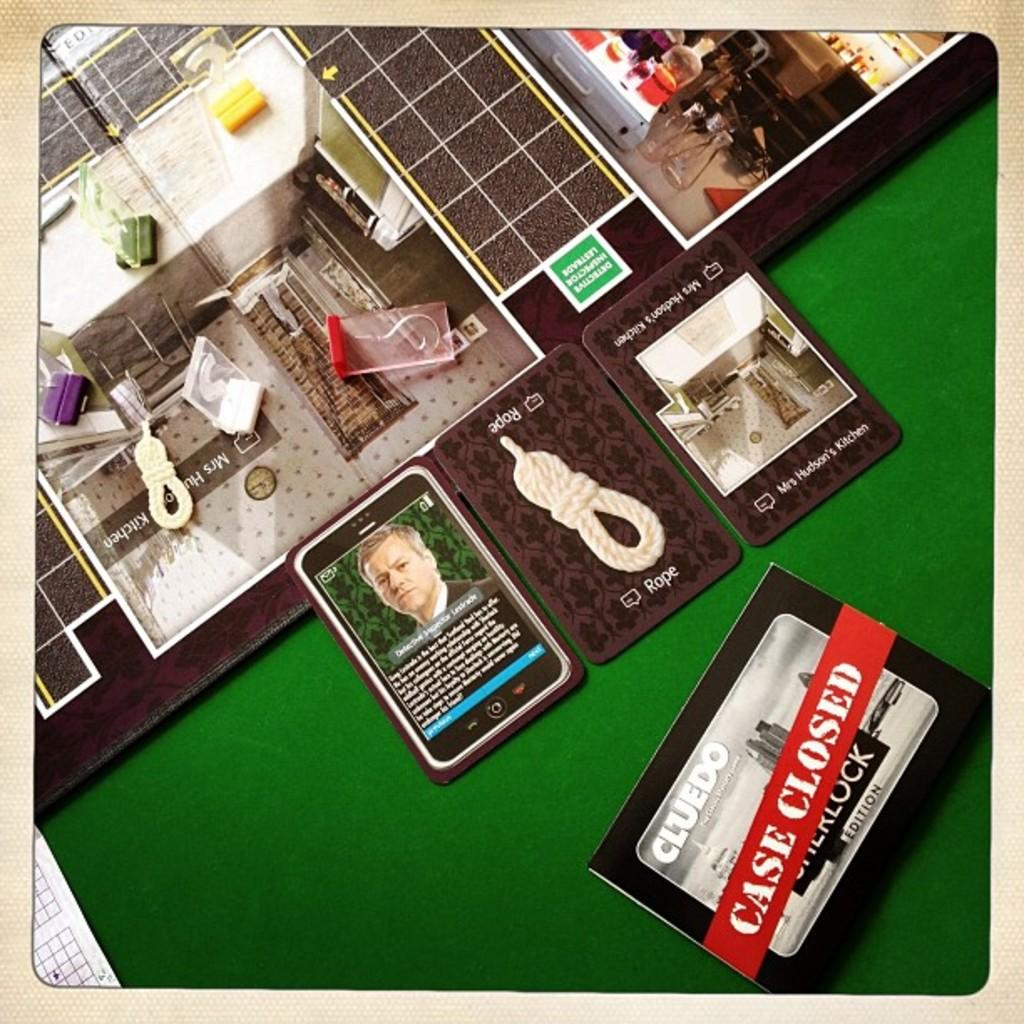<image>
Create a compact narrative representing the image presented. Clues that helped solved the mystery while playing a game of clues. 